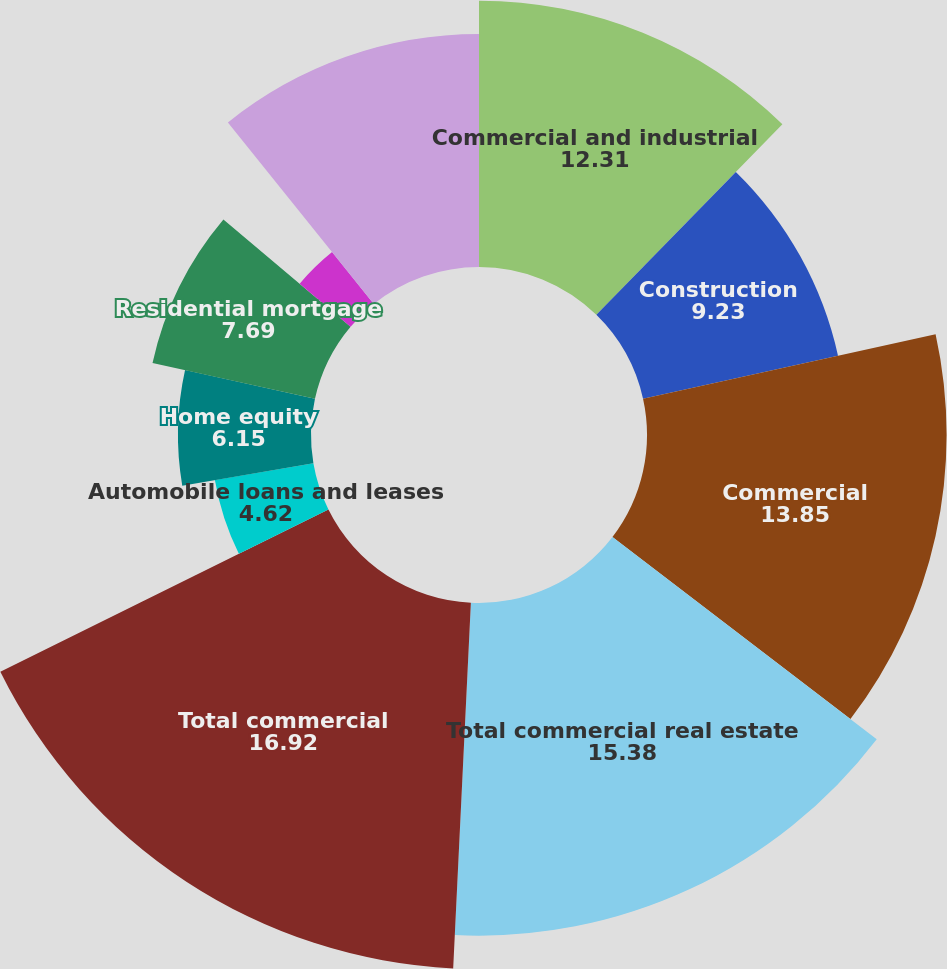Convert chart. <chart><loc_0><loc_0><loc_500><loc_500><pie_chart><fcel>Commercial and industrial<fcel>Construction<fcel>Commercial<fcel>Total commercial real estate<fcel>Total commercial<fcel>Automobile loans and leases<fcel>Home equity<fcel>Residential mortgage<fcel>Other loans<fcel>Total consumer<nl><fcel>12.31%<fcel>9.23%<fcel>13.85%<fcel>15.38%<fcel>16.92%<fcel>4.62%<fcel>6.15%<fcel>7.69%<fcel>3.08%<fcel>10.77%<nl></chart> 